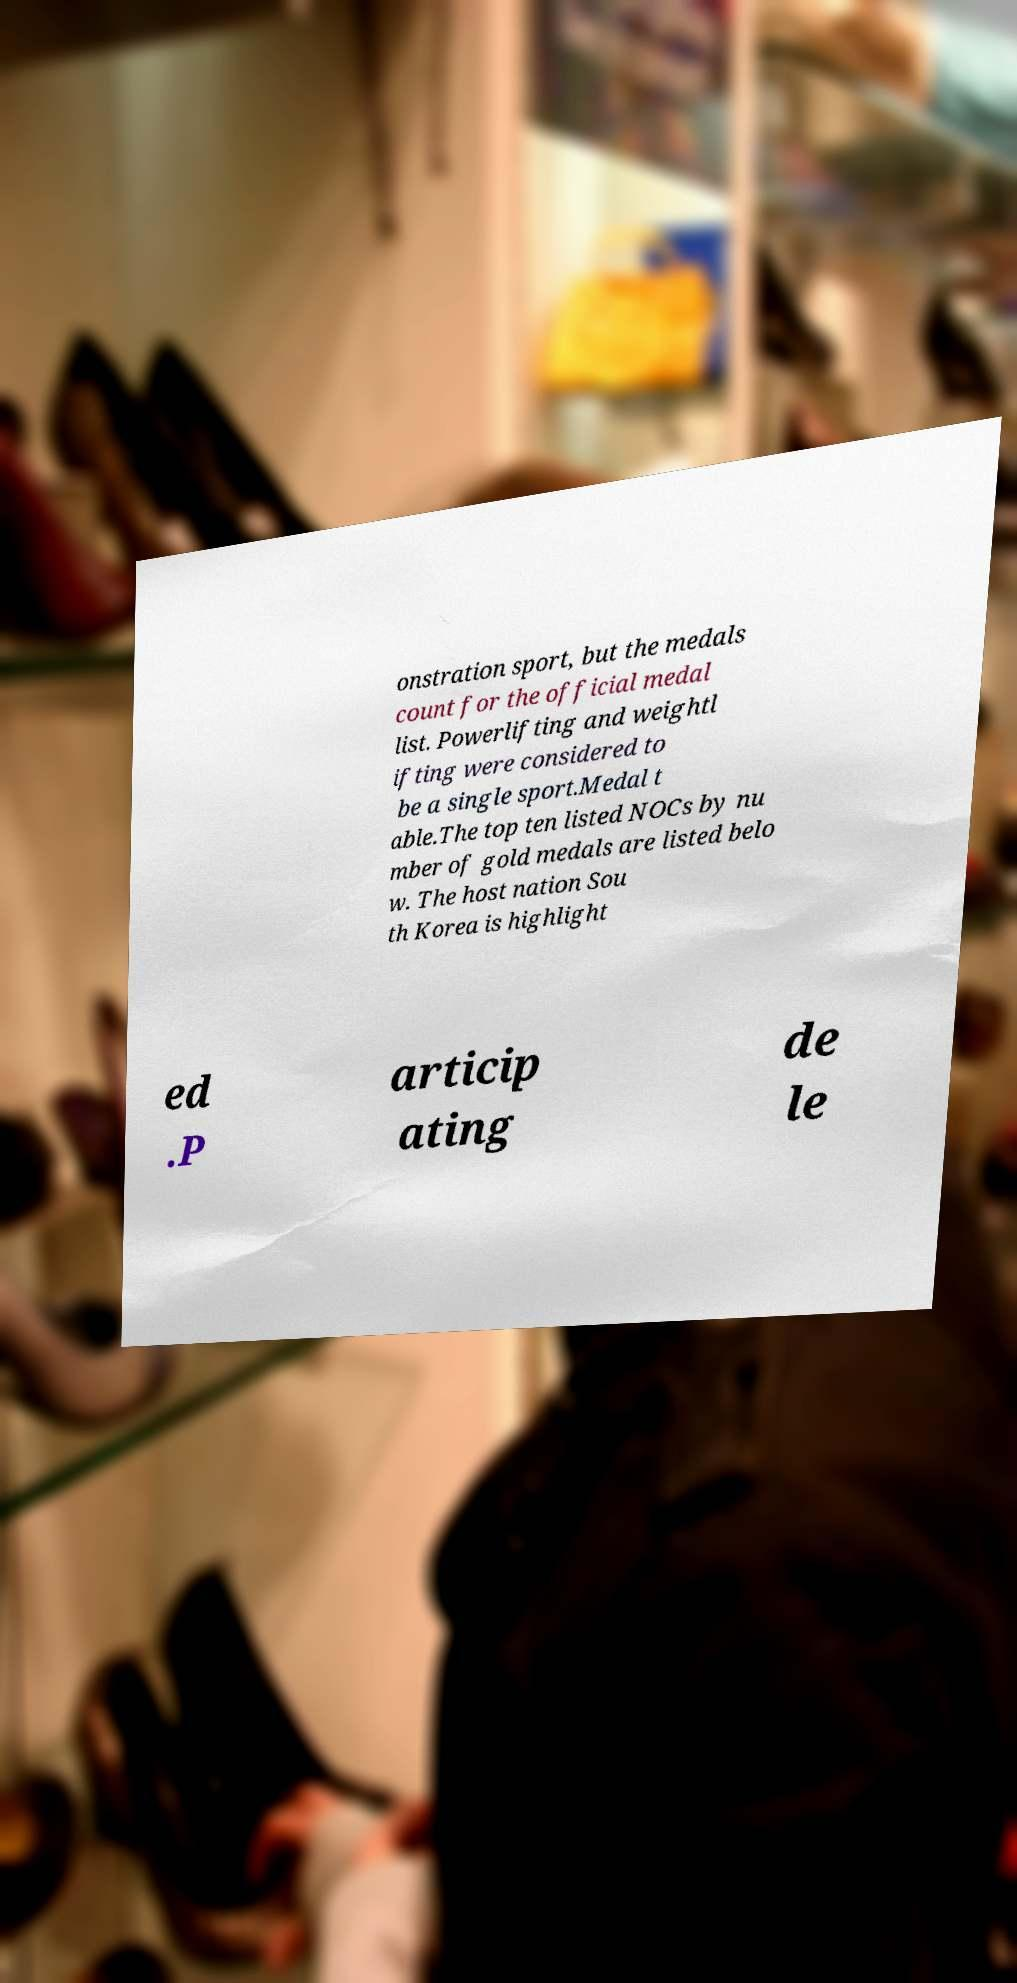Can you accurately transcribe the text from the provided image for me? onstration sport, but the medals count for the official medal list. Powerlifting and weightl ifting were considered to be a single sport.Medal t able.The top ten listed NOCs by nu mber of gold medals are listed belo w. The host nation Sou th Korea is highlight ed .P articip ating de le 